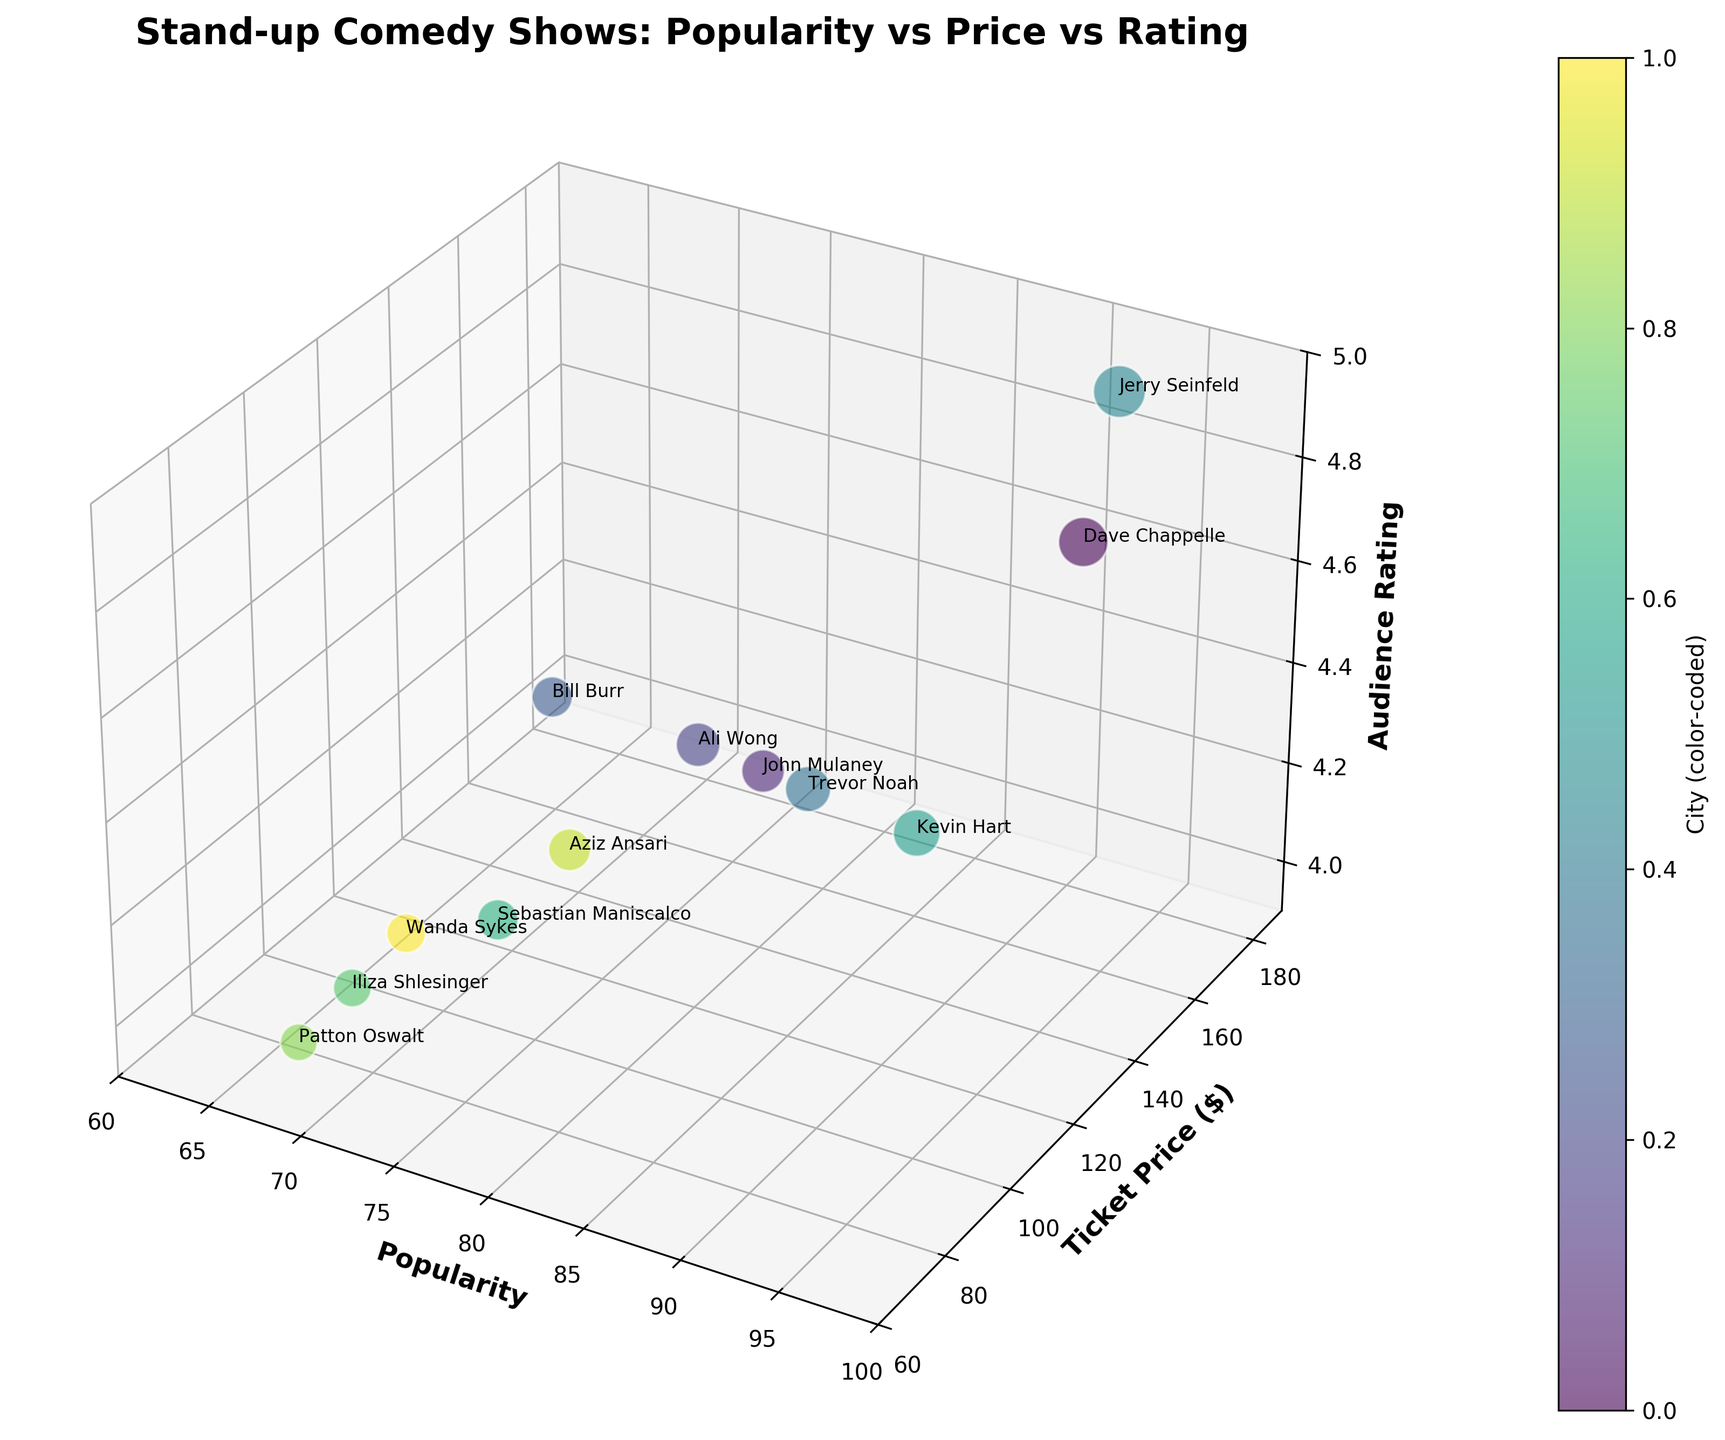How many comedians are shown in the chart? Count the number of data points (or bubbles) representing each comedian in the chart.
Answer: 12 What's the highest ticket price among the stand-up comedy shows? Identify the highest value along the Ticket Price ($) axis.
Answer: $180 Which comedian has the highest audience rating? Locate the point with the highest value on the Audience Rating axis.
Answer: Jerry Seinfeld What is the average popularity of comedians in the chart? Sum the popularity values and divide by the number of comedians ( (95+88+82+79+86+92+90+75+70+68+77+72) / 12 )
Answer: 81.3 How do the ticket prices of Dave Chappelle and Kevin Hart compare? Find the Ticket Price values for both Dave Chappelle and Kevin Hart and compare them.
Answer: Dave Chappelle's ticket price is $150 and Kevin Hart's is $130, so Dave Chappelle has a higher ticket price Which city hosts the comedy show with the lowest audience rating? Identify the lowest value on the Audience Rating axis and check which city corresponds to this value.
Answer: Seattle Compare the popularity and audience rating of Bill Burr and Aziz Ansari. Who has higher ratings in each category? Check the values for both comedians under Popularity and Audience Rating.
Answer: Bill Burr is more popular (79 vs. 77) and has a higher audience rating (4.7 vs. 4.3) What is the range of ticket prices for the comedy shows? Subtract the minimum ticket price from the maximum ticket price (180 - 70).
Answer: $110 Are there any comedians with both popularity above 90 and audience rating above 4.7? Check the points on the chart that meet both criteria.
Answer: Dave Chappelle and Jerry Seinfeld Which comedian has the most expensive average ticket price but a relatively low popularity score? Locate the comedian with the highest ticket price and a comparatively lower popularity.
Answer: Jerry Seinfeld 